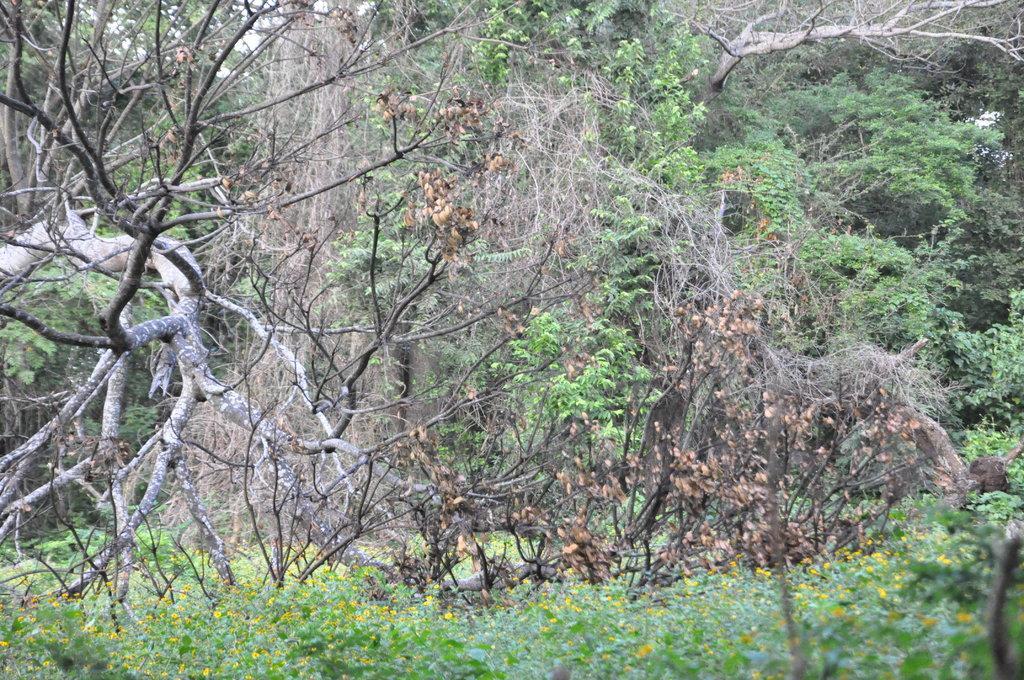Describe this image in one or two sentences. In this image we can see the trees and at the bottom there are plants with flowers. 